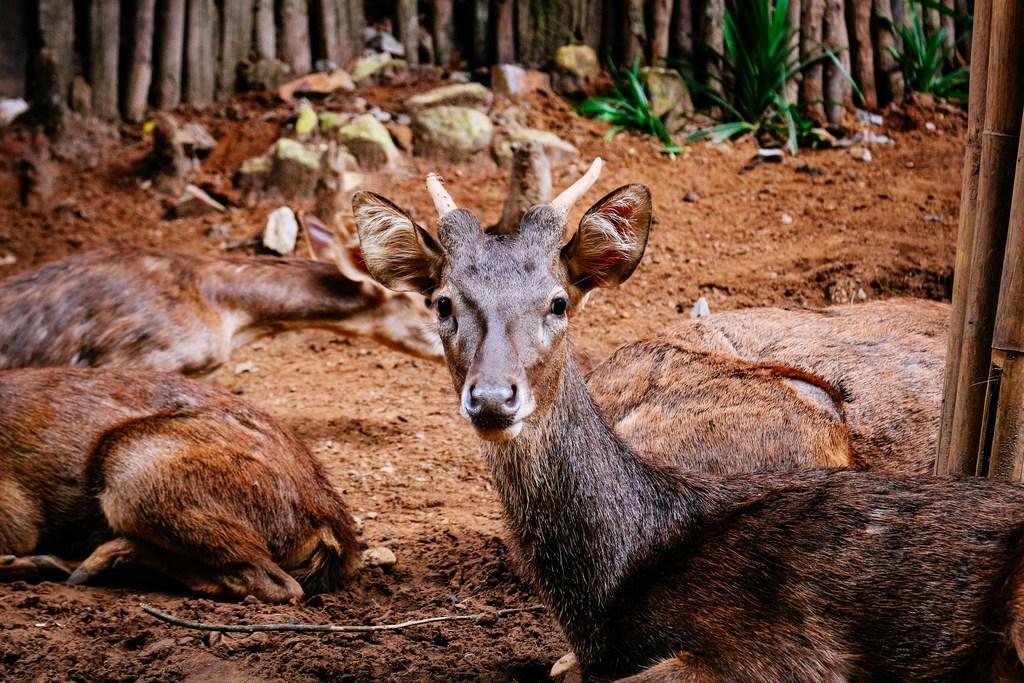Can you describe this image briefly? In this picture we can see deer on the ground and in the background we can see wooden poles,plants. 